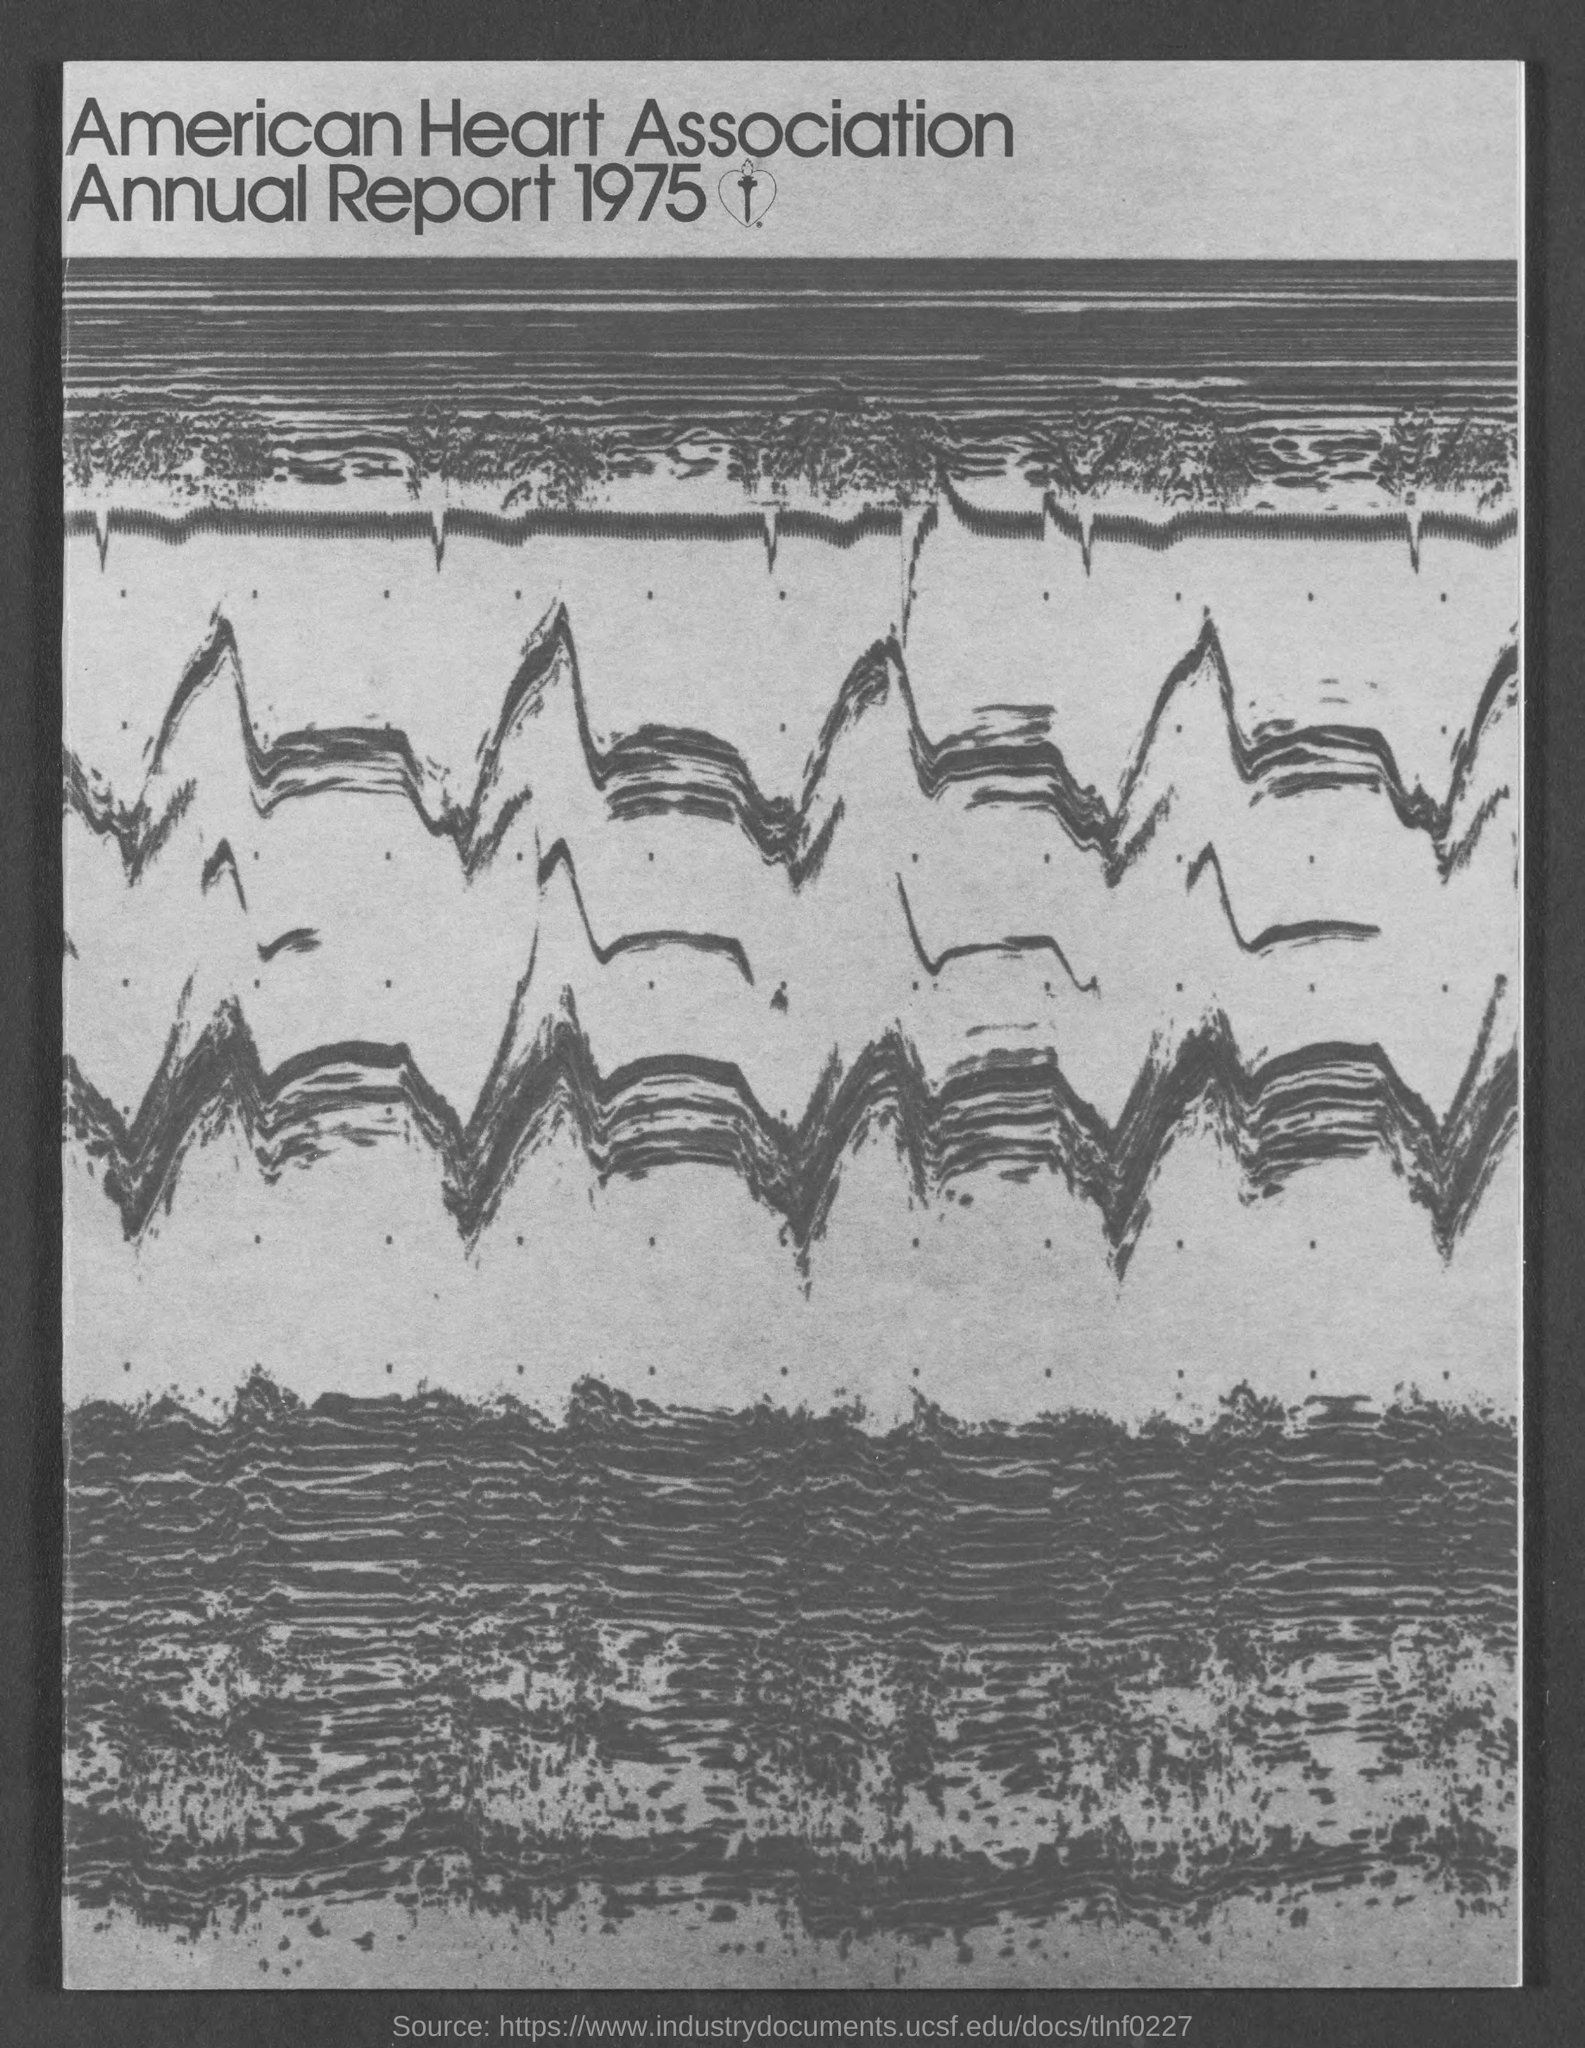Identify some key points in this picture. The American Heart Association Annual Report 1975 is mentioned. 